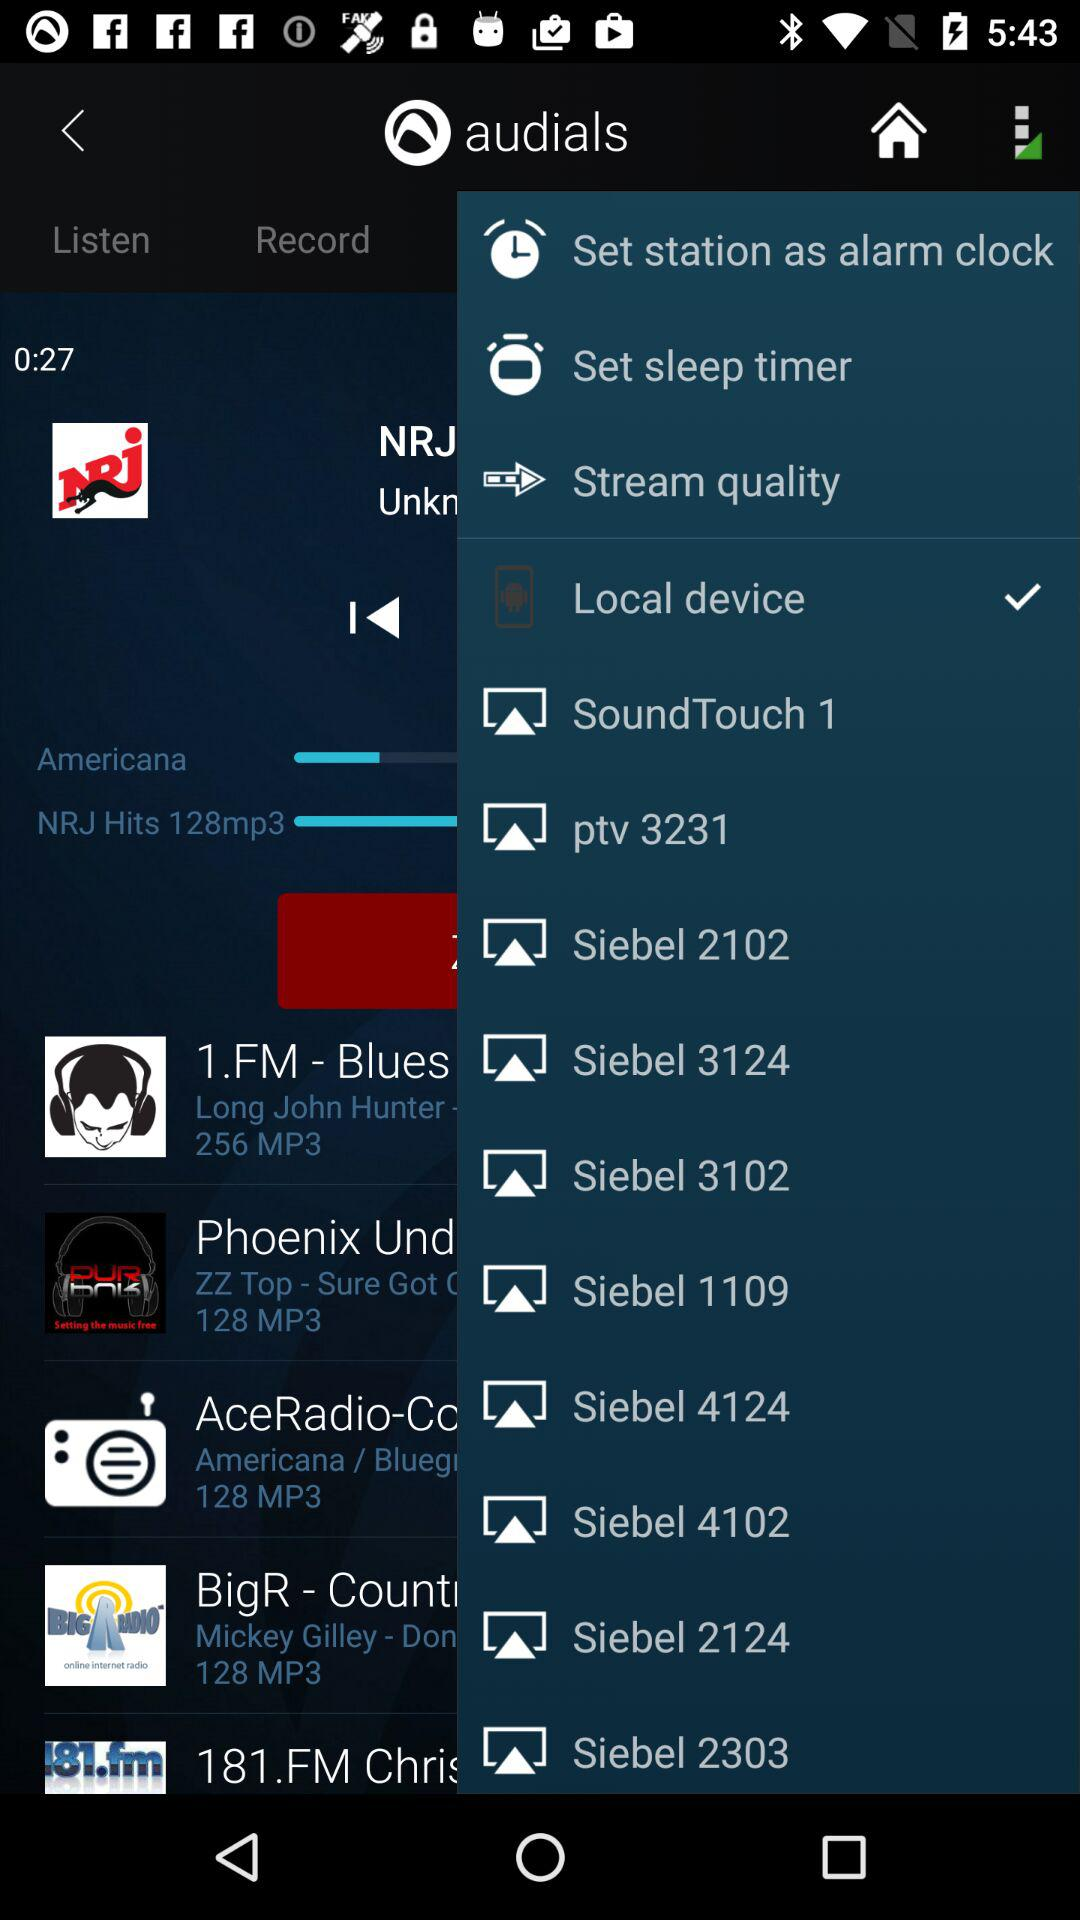Which item has been selected? The item "Local device" has been selected. 